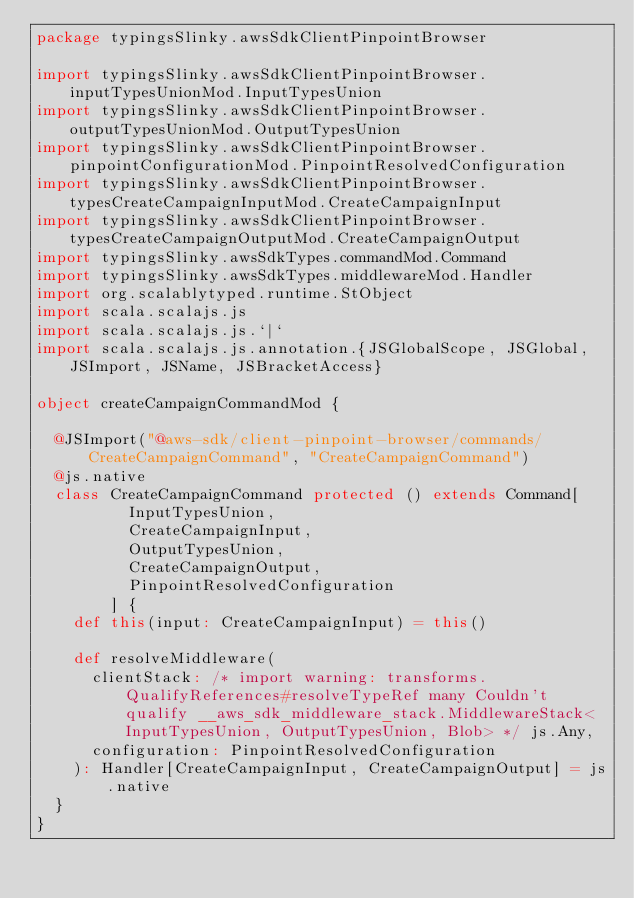<code> <loc_0><loc_0><loc_500><loc_500><_Scala_>package typingsSlinky.awsSdkClientPinpointBrowser

import typingsSlinky.awsSdkClientPinpointBrowser.inputTypesUnionMod.InputTypesUnion
import typingsSlinky.awsSdkClientPinpointBrowser.outputTypesUnionMod.OutputTypesUnion
import typingsSlinky.awsSdkClientPinpointBrowser.pinpointConfigurationMod.PinpointResolvedConfiguration
import typingsSlinky.awsSdkClientPinpointBrowser.typesCreateCampaignInputMod.CreateCampaignInput
import typingsSlinky.awsSdkClientPinpointBrowser.typesCreateCampaignOutputMod.CreateCampaignOutput
import typingsSlinky.awsSdkTypes.commandMod.Command
import typingsSlinky.awsSdkTypes.middlewareMod.Handler
import org.scalablytyped.runtime.StObject
import scala.scalajs.js
import scala.scalajs.js.`|`
import scala.scalajs.js.annotation.{JSGlobalScope, JSGlobal, JSImport, JSName, JSBracketAccess}

object createCampaignCommandMod {
  
  @JSImport("@aws-sdk/client-pinpoint-browser/commands/CreateCampaignCommand", "CreateCampaignCommand")
  @js.native
  class CreateCampaignCommand protected () extends Command[
          InputTypesUnion, 
          CreateCampaignInput, 
          OutputTypesUnion, 
          CreateCampaignOutput, 
          PinpointResolvedConfiguration
        ] {
    def this(input: CreateCampaignInput) = this()
    
    def resolveMiddleware(
      clientStack: /* import warning: transforms.QualifyReferences#resolveTypeRef many Couldn't qualify __aws_sdk_middleware_stack.MiddlewareStack<InputTypesUnion, OutputTypesUnion, Blob> */ js.Any,
      configuration: PinpointResolvedConfiguration
    ): Handler[CreateCampaignInput, CreateCampaignOutput] = js.native
  }
}
</code> 